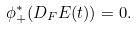Convert formula to latex. <formula><loc_0><loc_0><loc_500><loc_500>\phi _ { + } ^ { * } ( D _ { F } E ( t ) ) = 0 .</formula> 